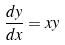Convert formula to latex. <formula><loc_0><loc_0><loc_500><loc_500>\frac { d y } { d x } = x y</formula> 